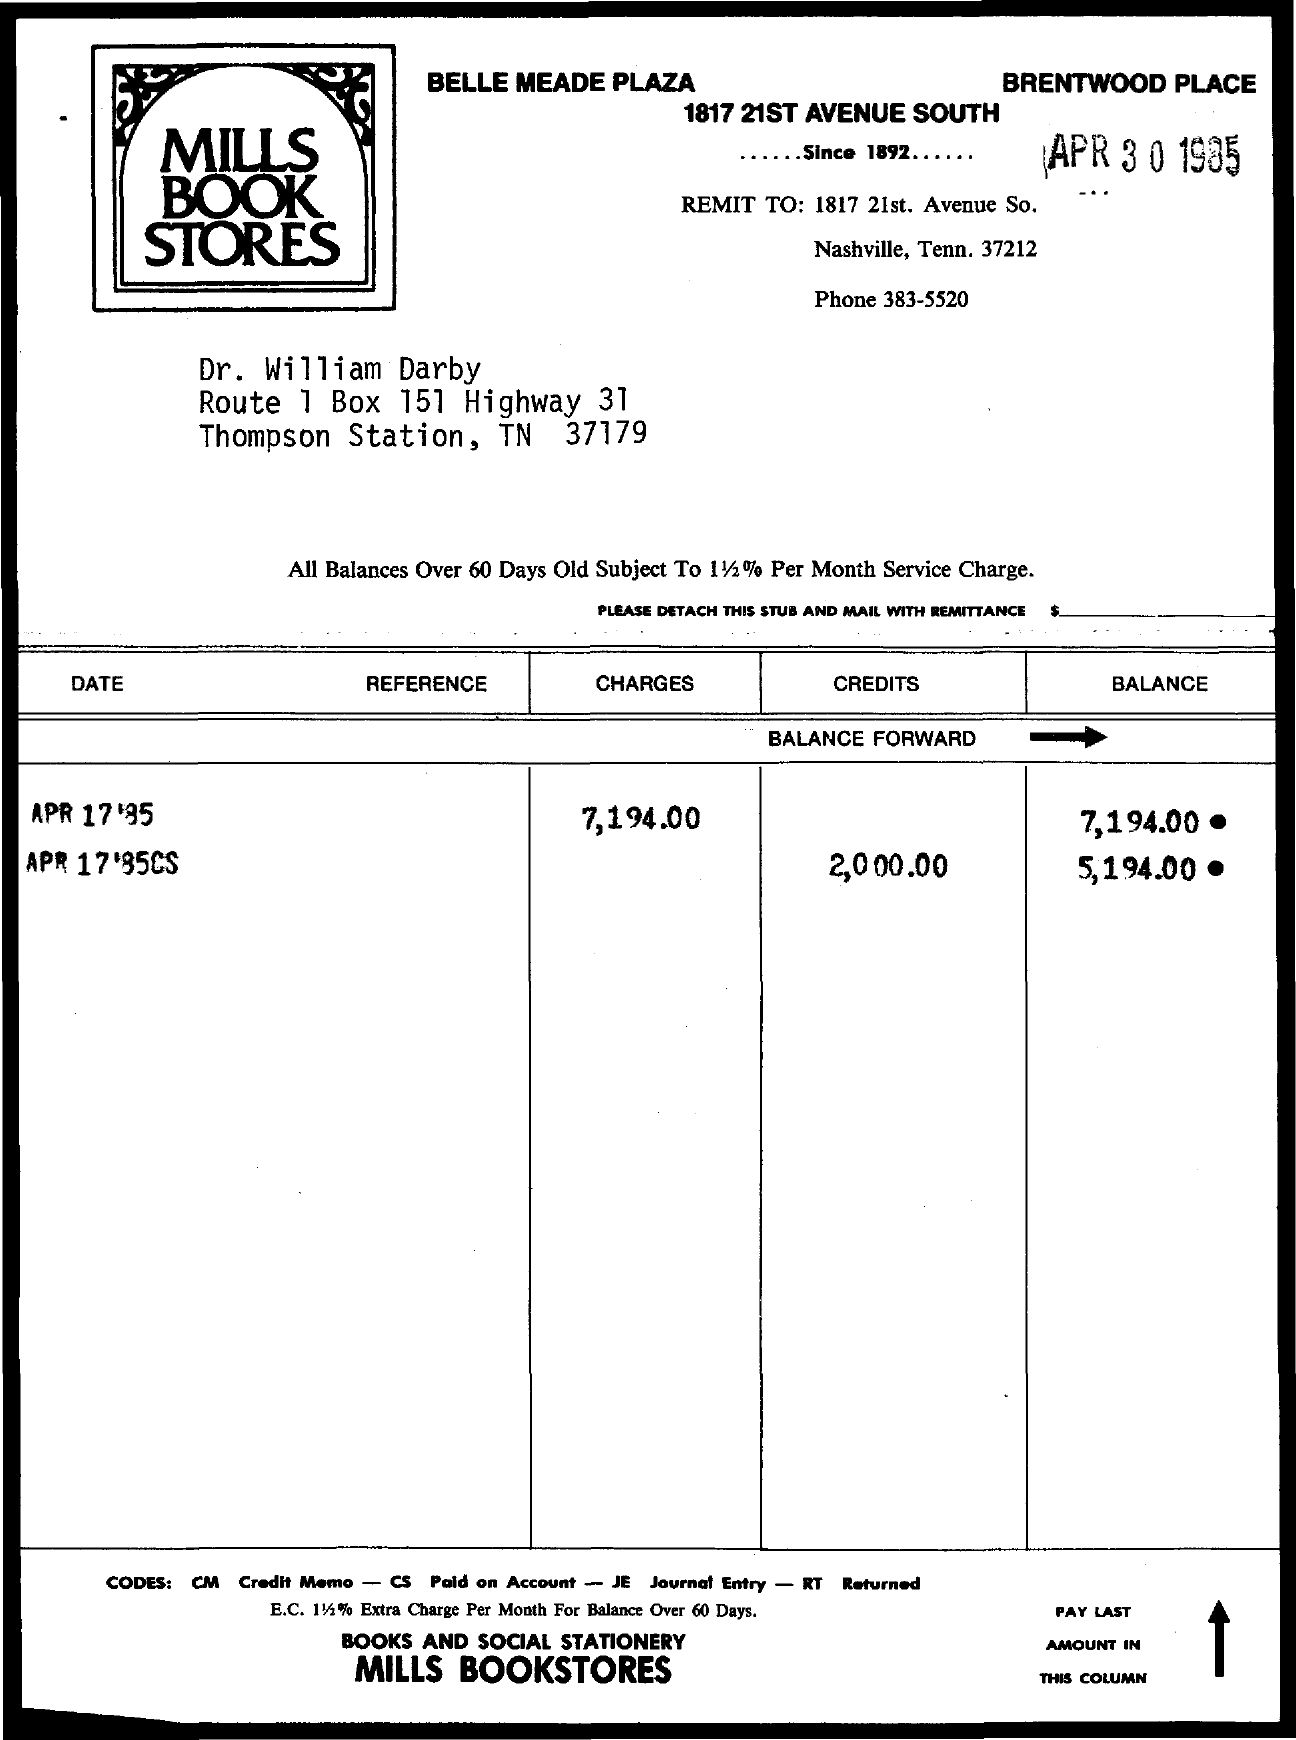What is the Phone Number ?
Make the answer very short. 383-5520. What is the BoX number ?
Your answer should be compact. 151. 